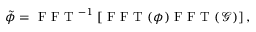Convert formula to latex. <formula><loc_0><loc_0><loc_500><loc_500>\tilde { \phi } = F F T ^ { - 1 } \left [ F F T ( \phi ) F F T ( \mathcal { G } ) \right ] ,</formula> 